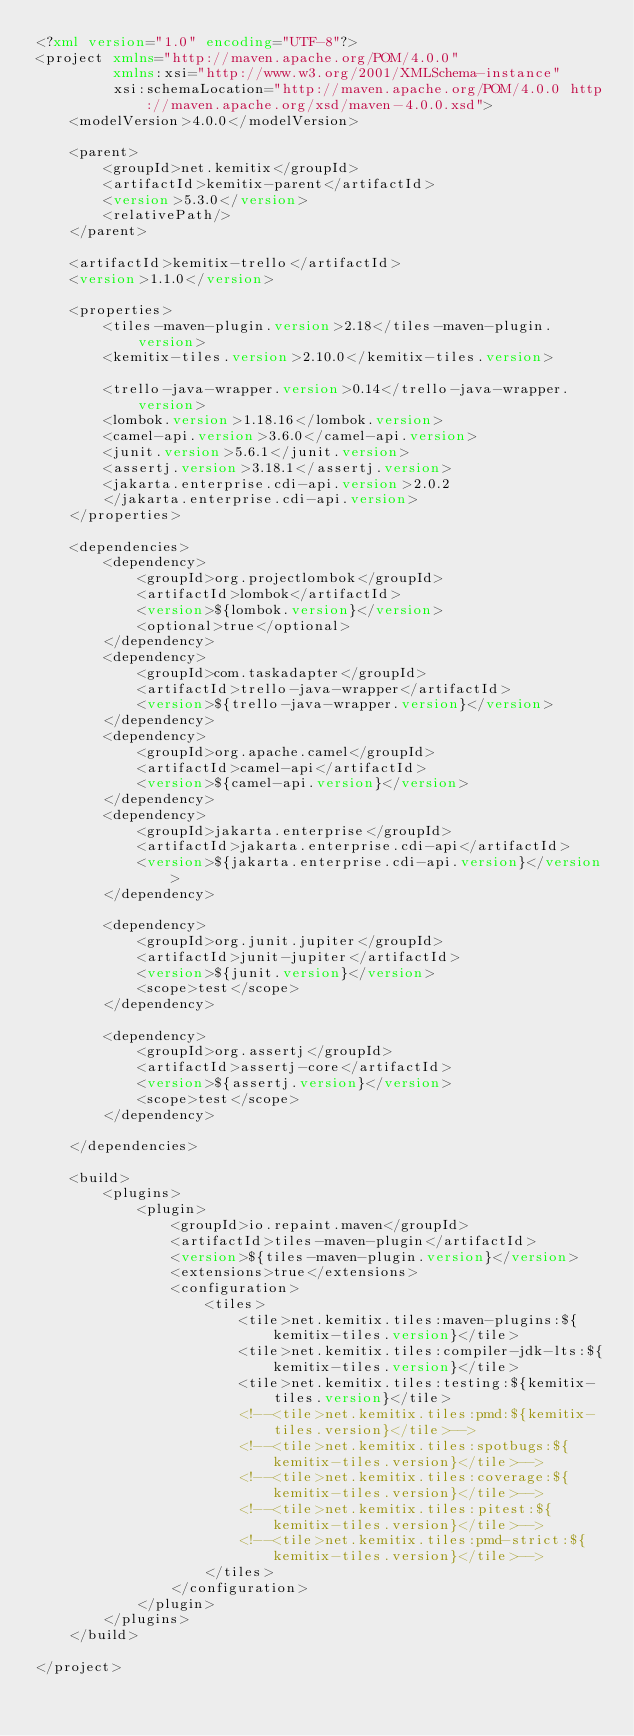<code> <loc_0><loc_0><loc_500><loc_500><_XML_><?xml version="1.0" encoding="UTF-8"?>
<project xmlns="http://maven.apache.org/POM/4.0.0"
         xmlns:xsi="http://www.w3.org/2001/XMLSchema-instance"
         xsi:schemaLocation="http://maven.apache.org/POM/4.0.0 http://maven.apache.org/xsd/maven-4.0.0.xsd">
    <modelVersion>4.0.0</modelVersion>

    <parent>
        <groupId>net.kemitix</groupId>
        <artifactId>kemitix-parent</artifactId>
        <version>5.3.0</version>
        <relativePath/>
    </parent>

    <artifactId>kemitix-trello</artifactId>
    <version>1.1.0</version>

    <properties>
        <tiles-maven-plugin.version>2.18</tiles-maven-plugin.version>
        <kemitix-tiles.version>2.10.0</kemitix-tiles.version>

        <trello-java-wrapper.version>0.14</trello-java-wrapper.version>
        <lombok.version>1.18.16</lombok.version>
        <camel-api.version>3.6.0</camel-api.version>
        <junit.version>5.6.1</junit.version>
        <assertj.version>3.18.1</assertj.version>
        <jakarta.enterprise.cdi-api.version>2.0.2
        </jakarta.enterprise.cdi-api.version>
    </properties>

    <dependencies>
        <dependency>
            <groupId>org.projectlombok</groupId>
            <artifactId>lombok</artifactId>
            <version>${lombok.version}</version>
            <optional>true</optional>
        </dependency>
        <dependency>
            <groupId>com.taskadapter</groupId>
            <artifactId>trello-java-wrapper</artifactId>
            <version>${trello-java-wrapper.version}</version>
        </dependency>
        <dependency>
            <groupId>org.apache.camel</groupId>
            <artifactId>camel-api</artifactId>
            <version>${camel-api.version}</version>
        </dependency>
        <dependency>
            <groupId>jakarta.enterprise</groupId>
            <artifactId>jakarta.enterprise.cdi-api</artifactId>
            <version>${jakarta.enterprise.cdi-api.version}</version>
        </dependency>

        <dependency>
            <groupId>org.junit.jupiter</groupId>
            <artifactId>junit-jupiter</artifactId>
            <version>${junit.version}</version>
            <scope>test</scope>
        </dependency>

        <dependency>
            <groupId>org.assertj</groupId>
            <artifactId>assertj-core</artifactId>
            <version>${assertj.version}</version>
            <scope>test</scope>
        </dependency>

    </dependencies>

    <build>
        <plugins>
            <plugin>
                <groupId>io.repaint.maven</groupId>
                <artifactId>tiles-maven-plugin</artifactId>
                <version>${tiles-maven-plugin.version}</version>
                <extensions>true</extensions>
                <configuration>
                    <tiles>
                        <tile>net.kemitix.tiles:maven-plugins:${kemitix-tiles.version}</tile>
                        <tile>net.kemitix.tiles:compiler-jdk-lts:${kemitix-tiles.version}</tile>
                        <tile>net.kemitix.tiles:testing:${kemitix-tiles.version}</tile>
                        <!--<tile>net.kemitix.tiles:pmd:${kemitix-tiles.version}</tile>-->
                        <!--<tile>net.kemitix.tiles:spotbugs:${kemitix-tiles.version}</tile>-->
                        <!--<tile>net.kemitix.tiles:coverage:${kemitix-tiles.version}</tile>-->
                        <!--<tile>net.kemitix.tiles:pitest:${kemitix-tiles.version}</tile>-->
                        <!--<tile>net.kemitix.tiles:pmd-strict:${kemitix-tiles.version}</tile>-->
                    </tiles>
                </configuration>
            </plugin>
        </plugins>
    </build>

</project></code> 